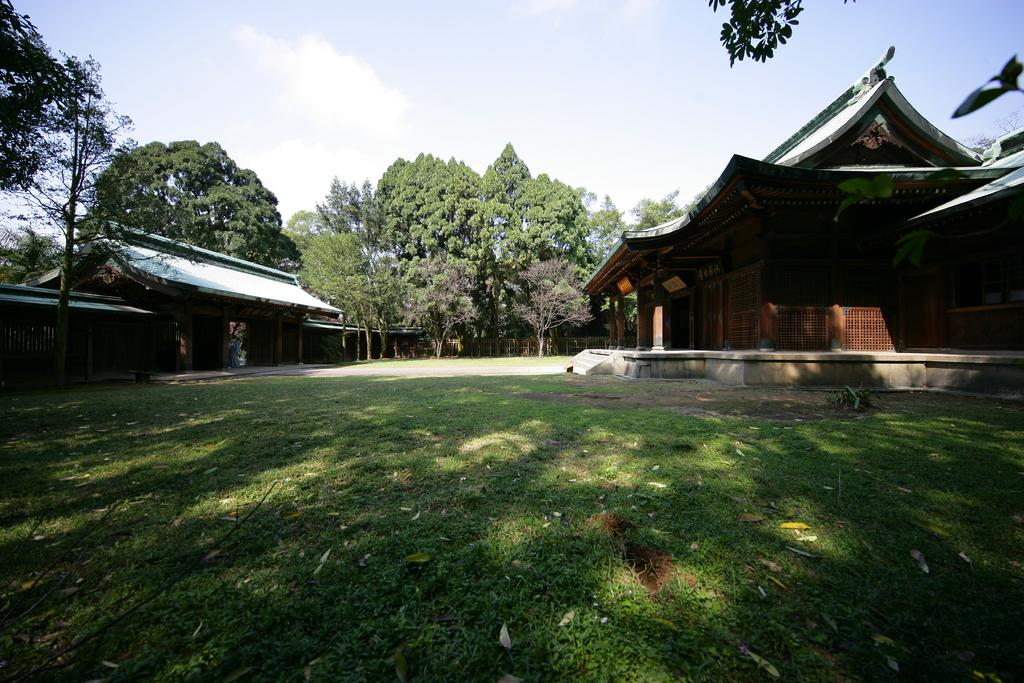What type of vegetation is present in the image? There is grass in the image. What type of structures can be seen in the image? There are houses in the image. What other natural elements are present in the image? There are trees in the image. What is visible in the background of the image? The sky is visible in the image. What color is the cloud in the image? There is no cloud present in the image; only the sky is visible. How many suns are visible in the image? There is only one sun visible in the image. 